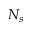Convert formula to latex. <formula><loc_0><loc_0><loc_500><loc_500>N _ { s }</formula> 